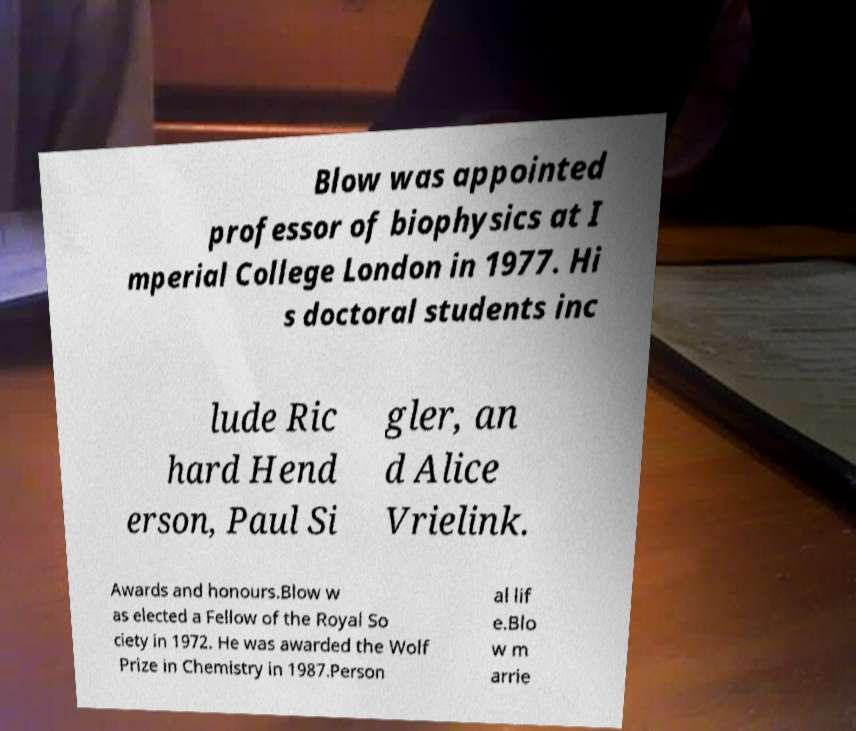For documentation purposes, I need the text within this image transcribed. Could you provide that? Blow was appointed professor of biophysics at I mperial College London in 1977. Hi s doctoral students inc lude Ric hard Hend erson, Paul Si gler, an d Alice Vrielink. Awards and honours.Blow w as elected a Fellow of the Royal So ciety in 1972. He was awarded the Wolf Prize in Chemistry in 1987.Person al lif e.Blo w m arrie 